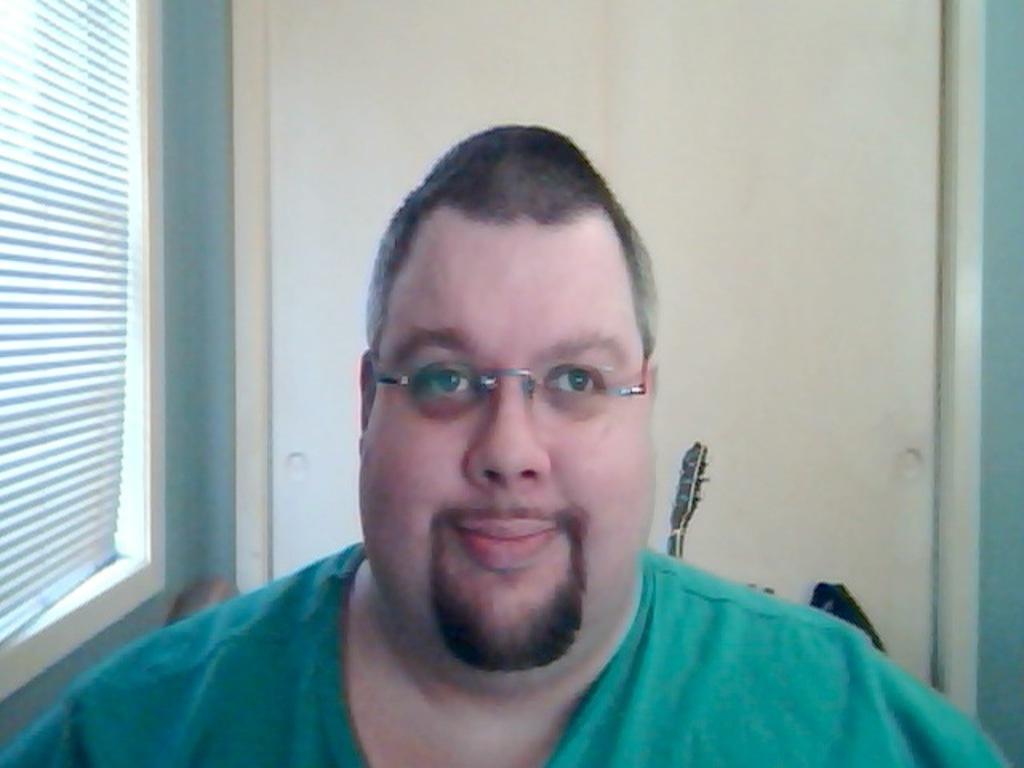Describe this image in one or two sentences. In front of the image there is a person having a smile on his face. Behind him there are some objects. In the background of the image there is a wall. On the left side of the image there is a window. 